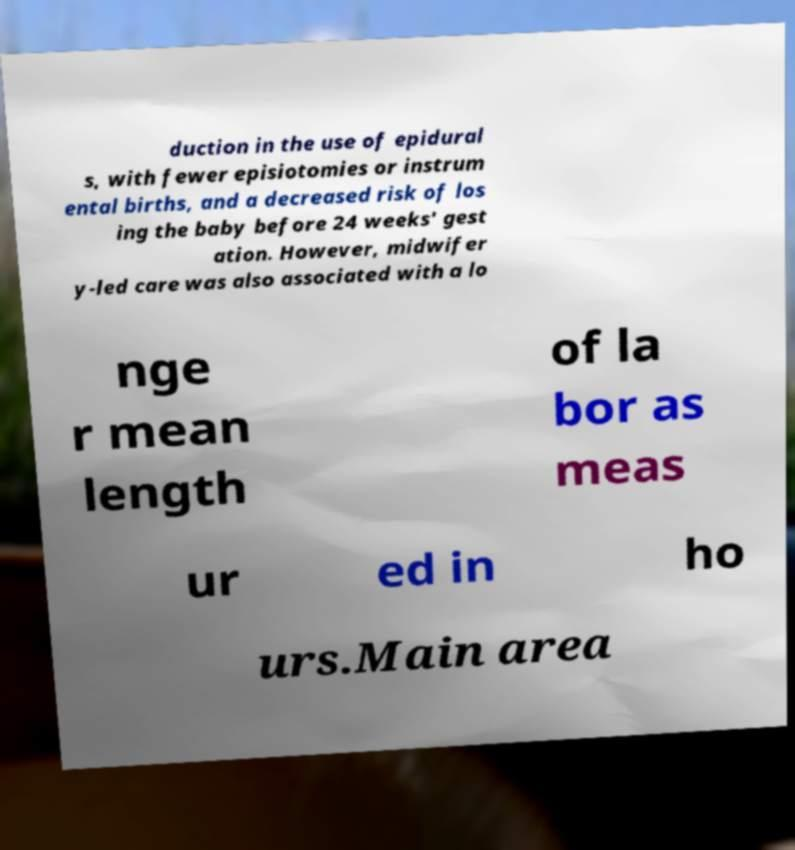I need the written content from this picture converted into text. Can you do that? duction in the use of epidural s, with fewer episiotomies or instrum ental births, and a decreased risk of los ing the baby before 24 weeks' gest ation. However, midwifer y-led care was also associated with a lo nge r mean length of la bor as meas ur ed in ho urs.Main area 